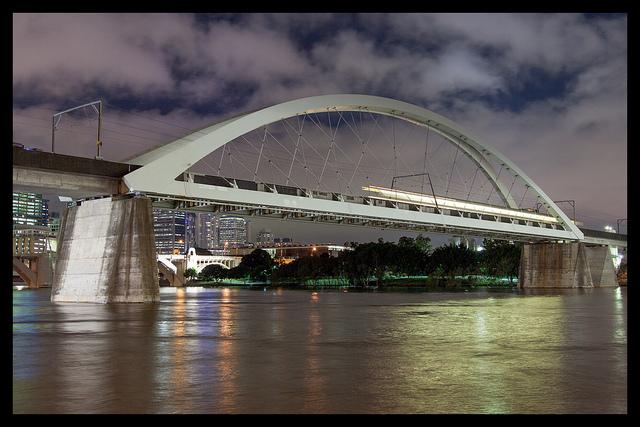What color are the main lights on the archway?
Be succinct. White. Does it look like it's going to rain?
Concise answer only. Yes. What type of clouds are pictured?
Write a very short answer. Cumulus. Is this a time-lapse photo?
Write a very short answer. No. 